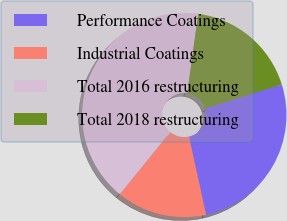<chart> <loc_0><loc_0><loc_500><loc_500><pie_chart><fcel>Performance Coatings<fcel>Industrial Coatings<fcel>Total 2016 restructuring<fcel>Total 2018 restructuring<nl><fcel>26.41%<fcel>14.29%<fcel>41.34%<fcel>17.97%<nl></chart> 